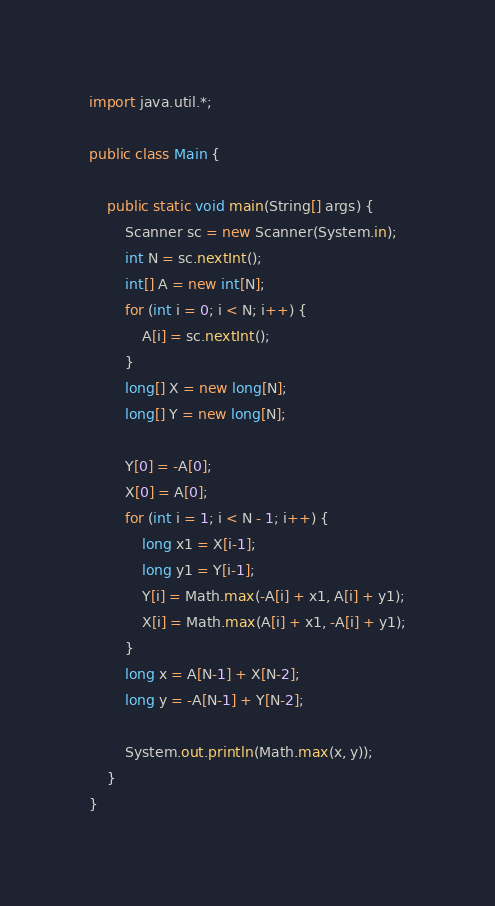<code> <loc_0><loc_0><loc_500><loc_500><_Java_>import java.util.*;

public class Main {

	public static void main(String[] args) {
		Scanner sc = new Scanner(System.in);
		int N = sc.nextInt();
		int[] A = new int[N];
		for (int i = 0; i < N; i++) {
			A[i] = sc.nextInt();
		}
		long[] X = new long[N];
		long[] Y = new long[N];

		Y[0] = -A[0];
		X[0] = A[0];
		for (int i = 1; i < N - 1; i++) {
			long x1 = X[i-1];
			long y1 = Y[i-1];
			Y[i] = Math.max(-A[i] + x1, A[i] + y1);
			X[i] = Math.max(A[i] + x1, -A[i] + y1);
		}
		long x = A[N-1] + X[N-2];
		long y = -A[N-1] + Y[N-2];

		System.out.println(Math.max(x, y));
	}
}
</code> 